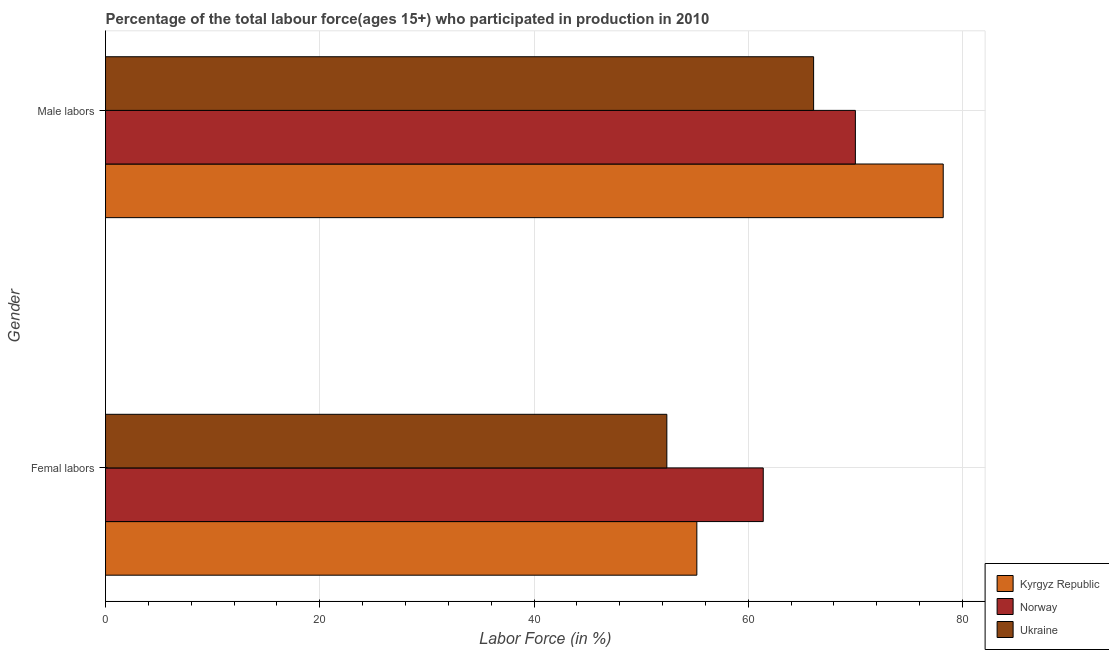How many bars are there on the 2nd tick from the top?
Provide a succinct answer. 3. What is the label of the 1st group of bars from the top?
Offer a terse response. Male labors. What is the percentage of male labour force in Kyrgyz Republic?
Your answer should be very brief. 78.2. Across all countries, what is the maximum percentage of male labour force?
Keep it short and to the point. 78.2. Across all countries, what is the minimum percentage of female labor force?
Your answer should be compact. 52.4. In which country was the percentage of male labour force maximum?
Your answer should be compact. Kyrgyz Republic. In which country was the percentage of female labor force minimum?
Your answer should be very brief. Ukraine. What is the total percentage of male labour force in the graph?
Your answer should be compact. 214.3. What is the difference between the percentage of female labor force in Kyrgyz Republic and that in Ukraine?
Your answer should be compact. 2.8. What is the difference between the percentage of male labour force in Kyrgyz Republic and the percentage of female labor force in Norway?
Your answer should be very brief. 16.8. What is the average percentage of female labor force per country?
Give a very brief answer. 56.33. What is the difference between the percentage of female labor force and percentage of male labour force in Kyrgyz Republic?
Provide a short and direct response. -23. What is the ratio of the percentage of male labour force in Ukraine to that in Norway?
Provide a short and direct response. 0.94. Is the percentage of male labour force in Kyrgyz Republic less than that in Ukraine?
Give a very brief answer. No. In how many countries, is the percentage of male labour force greater than the average percentage of male labour force taken over all countries?
Provide a short and direct response. 1. What does the 2nd bar from the bottom in Femal labors represents?
Your answer should be very brief. Norway. How many bars are there?
Give a very brief answer. 6. Are the values on the major ticks of X-axis written in scientific E-notation?
Offer a very short reply. No. Does the graph contain any zero values?
Your answer should be compact. No. Where does the legend appear in the graph?
Offer a terse response. Bottom right. How many legend labels are there?
Ensure brevity in your answer.  3. How are the legend labels stacked?
Your response must be concise. Vertical. What is the title of the graph?
Offer a terse response. Percentage of the total labour force(ages 15+) who participated in production in 2010. What is the label or title of the X-axis?
Provide a short and direct response. Labor Force (in %). What is the label or title of the Y-axis?
Provide a short and direct response. Gender. What is the Labor Force (in %) in Kyrgyz Republic in Femal labors?
Your response must be concise. 55.2. What is the Labor Force (in %) in Norway in Femal labors?
Provide a succinct answer. 61.4. What is the Labor Force (in %) in Ukraine in Femal labors?
Provide a succinct answer. 52.4. What is the Labor Force (in %) of Kyrgyz Republic in Male labors?
Keep it short and to the point. 78.2. What is the Labor Force (in %) in Ukraine in Male labors?
Offer a very short reply. 66.1. Across all Gender, what is the maximum Labor Force (in %) of Kyrgyz Republic?
Your answer should be very brief. 78.2. Across all Gender, what is the maximum Labor Force (in %) in Ukraine?
Ensure brevity in your answer.  66.1. Across all Gender, what is the minimum Labor Force (in %) in Kyrgyz Republic?
Offer a very short reply. 55.2. Across all Gender, what is the minimum Labor Force (in %) of Norway?
Offer a very short reply. 61.4. Across all Gender, what is the minimum Labor Force (in %) in Ukraine?
Make the answer very short. 52.4. What is the total Labor Force (in %) in Kyrgyz Republic in the graph?
Keep it short and to the point. 133.4. What is the total Labor Force (in %) in Norway in the graph?
Make the answer very short. 131.4. What is the total Labor Force (in %) of Ukraine in the graph?
Your answer should be compact. 118.5. What is the difference between the Labor Force (in %) in Kyrgyz Republic in Femal labors and that in Male labors?
Make the answer very short. -23. What is the difference between the Labor Force (in %) of Ukraine in Femal labors and that in Male labors?
Offer a terse response. -13.7. What is the difference between the Labor Force (in %) of Kyrgyz Republic in Femal labors and the Labor Force (in %) of Norway in Male labors?
Ensure brevity in your answer.  -14.8. What is the difference between the Labor Force (in %) of Norway in Femal labors and the Labor Force (in %) of Ukraine in Male labors?
Ensure brevity in your answer.  -4.7. What is the average Labor Force (in %) of Kyrgyz Republic per Gender?
Offer a very short reply. 66.7. What is the average Labor Force (in %) of Norway per Gender?
Your answer should be compact. 65.7. What is the average Labor Force (in %) in Ukraine per Gender?
Give a very brief answer. 59.25. What is the difference between the Labor Force (in %) of Kyrgyz Republic and Labor Force (in %) of Ukraine in Femal labors?
Keep it short and to the point. 2.8. What is the difference between the Labor Force (in %) of Norway and Labor Force (in %) of Ukraine in Femal labors?
Provide a succinct answer. 9. What is the difference between the Labor Force (in %) in Kyrgyz Republic and Labor Force (in %) in Norway in Male labors?
Your answer should be compact. 8.2. What is the difference between the Labor Force (in %) in Kyrgyz Republic and Labor Force (in %) in Ukraine in Male labors?
Your response must be concise. 12.1. What is the ratio of the Labor Force (in %) of Kyrgyz Republic in Femal labors to that in Male labors?
Offer a very short reply. 0.71. What is the ratio of the Labor Force (in %) in Norway in Femal labors to that in Male labors?
Offer a terse response. 0.88. What is the ratio of the Labor Force (in %) of Ukraine in Femal labors to that in Male labors?
Offer a very short reply. 0.79. 